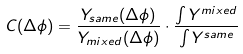Convert formula to latex. <formula><loc_0><loc_0><loc_500><loc_500>C ( \Delta \phi ) = \frac { Y _ { s a m e } ( \Delta \phi ) } { Y _ { m i x e d } ( \Delta \phi ) } \cdot \frac { \int Y ^ { m i x e d } } { \int Y ^ { s a m e } }</formula> 